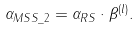<formula> <loc_0><loc_0><loc_500><loc_500>\alpha _ { M S S \_ 2 } = \alpha _ { R S } \cdot \beta ^ { ( l ) } .</formula> 